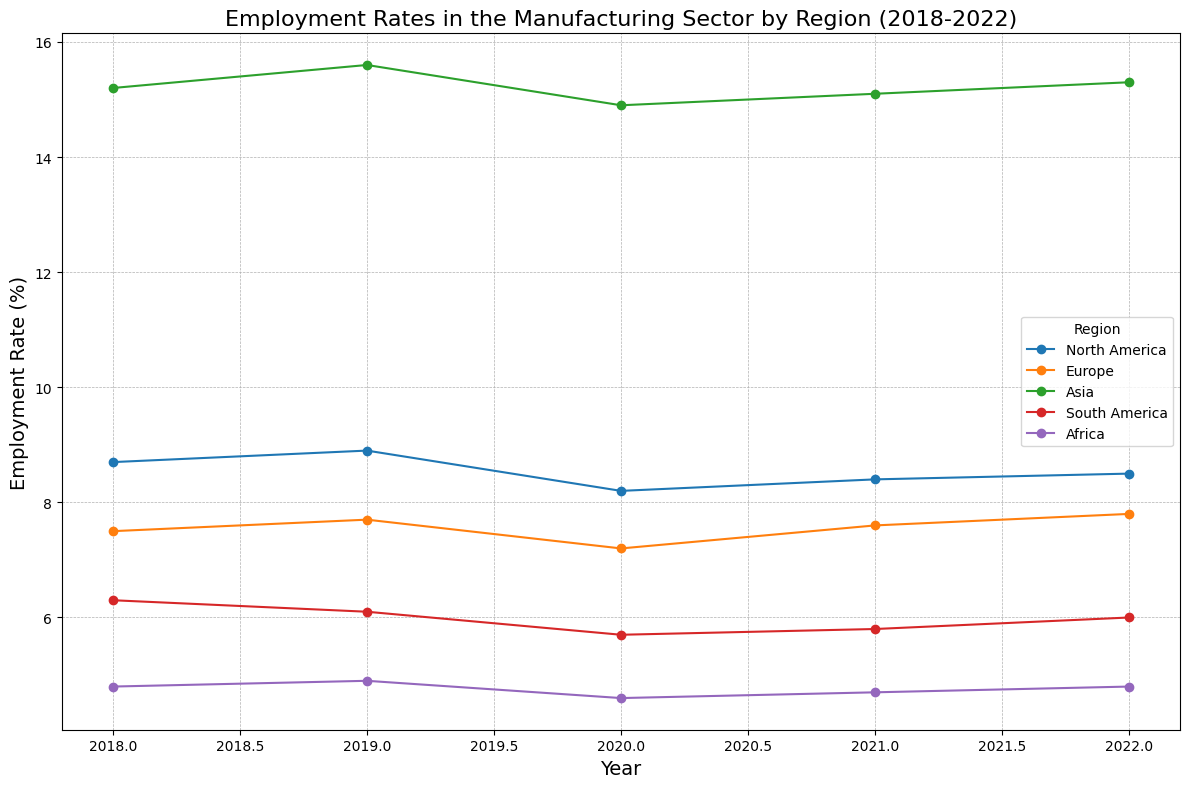Which region had the highest employment rate in 2018? In 2018, the region with the highest point on the graph would indicate the highest employment rate. From the figure, Asia shows the highest point at 15.2%.
Answer: Asia Between which years did North America see the greatest drop in employment rates? To determine the greatest drop, we look for the steepest decline between two consecutive years for North America. There is a drop from 8.9% in 2019 to 8.2% in 2020.
Answer: 2019-2020 What was the average employment rate in Europe between 2020 and 2022? To find the average, calculate the mean of the values for Europe in 2020 (7.2), 2021 (7.6), and 2022 (7.8). The average is (7.2 + 7.6 + 7.8) / 3.
Answer: 7.53 Which region experienced the most consistent employment rate from 2018 to 2022? The region with the least variation in the employment rate across the years would have the most consistent rate. By examining the variability of each line, we see that Africa has the most uniform rate around 4.6-4.8%.
Answer: Africa In 2020, how much higher was Asia's employment rate compared to South America? To find the difference, subtract South America's employment rate (5.7) from Asia's rate (14.9) for 2020. The difference is 14.9 - 5.7.
Answer: 9.2 Which two years show the largest increase in employment rate for Europe? To determine the largest increase, look for the years with the biggest positive difference between consecutive years. Europe's employment rate increased from 7.2 in 2020 to 7.6 in 2021, which is the largest increase of 0.4.
Answer: 2020-2021 What is the trend of employment rates in South America from 2018 to 2022? Observing South America's line, it started at 6.3 in 2018, dropped to 5.7 in 2020, and then increased slightly to 6.0 in 2022. The trend includes a decline followed by a slight recovery.
Answer: Decline and slight recovery Compare the employment rate change from 2020 to 2022 for Europe and North America. Which region had a greater change? Calculate the difference for both regions: Europe (7.8 - 7.2 = 0.6) and North America (8.5 - 8.2 = 0.3). Therefore, Europe had a greater change in employment rate.
Answer: Europe In which year did Africa see the highest employment rate, and what was it? Find the highest point on Africa’s line on the graph. In 2019, Africa had its highest rate at 4.9%.
Answer: 2019, 4.9 Looking at the overall trend from 2018 to 2022, which region shows the most growth in employment rate? By examining the trend lines, Asia shows an upward trend peaking in 2019. Despite fluctuations, consolidation of growth across the years shows an overall increase.
Answer: Asia 